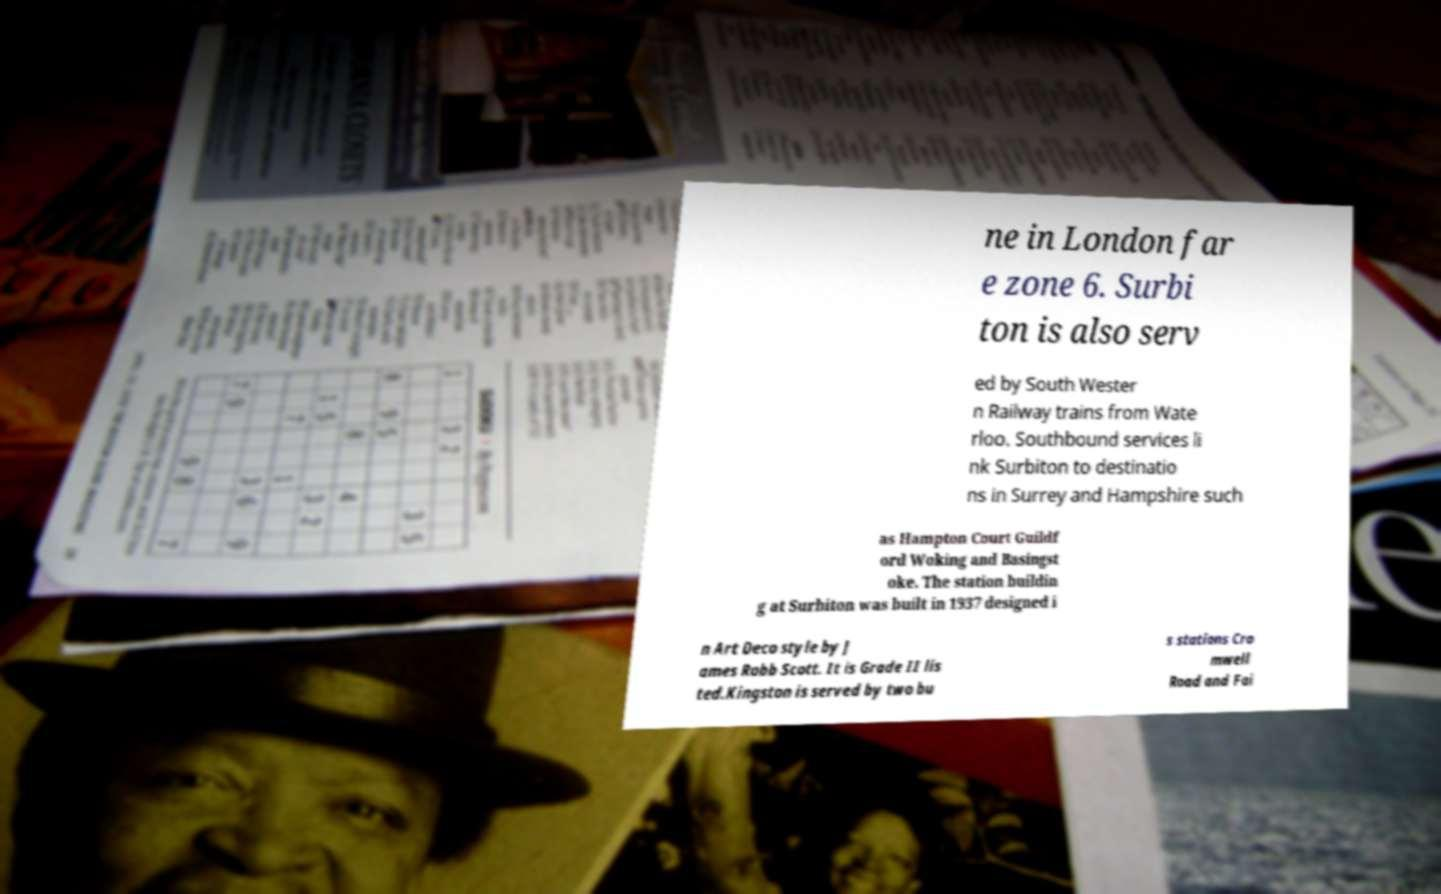For documentation purposes, I need the text within this image transcribed. Could you provide that? ne in London far e zone 6. Surbi ton is also serv ed by South Wester n Railway trains from Wate rloo. Southbound services li nk Surbiton to destinatio ns in Surrey and Hampshire such as Hampton Court Guildf ord Woking and Basingst oke. The station buildin g at Surbiton was built in 1937 designed i n Art Deco style by J ames Robb Scott. It is Grade II lis ted.Kingston is served by two bu s stations Cro mwell Road and Fai 